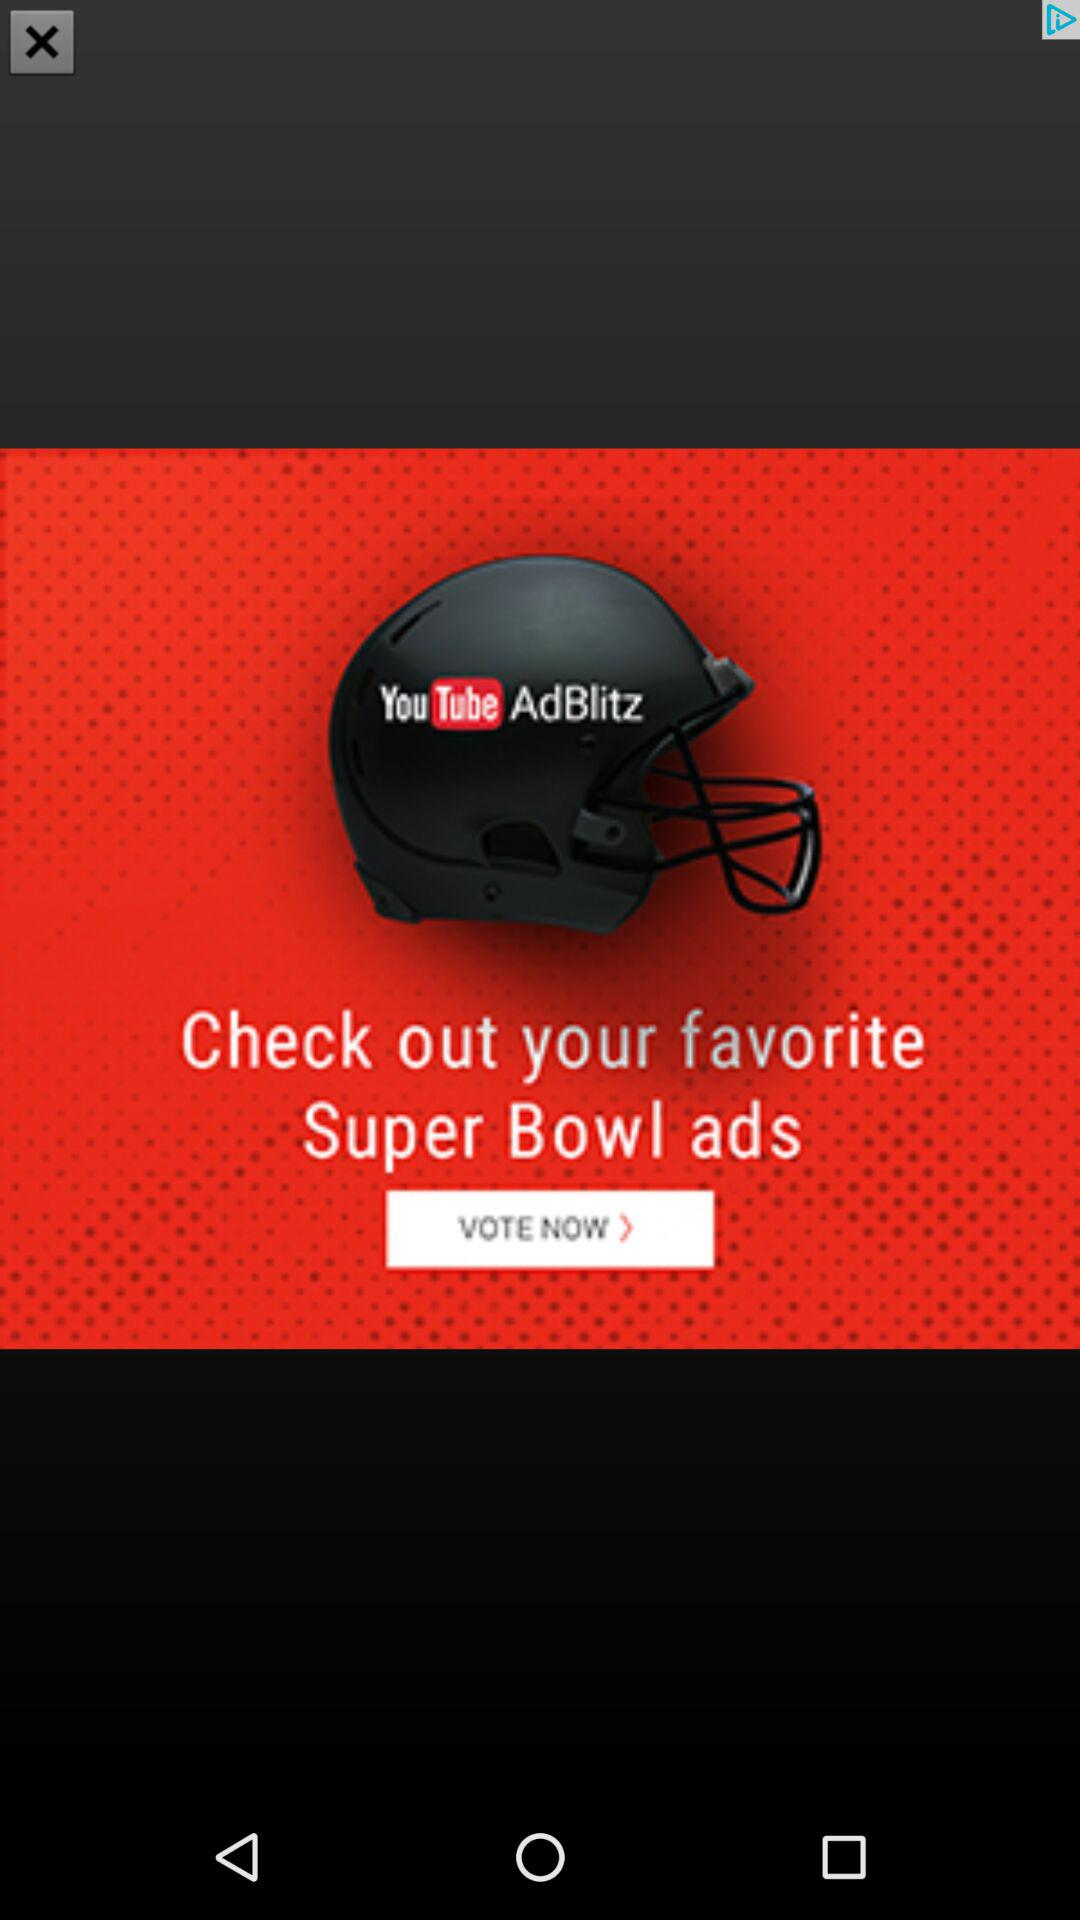What is the channel name? The channel name is "YouTube AdBlitz". 